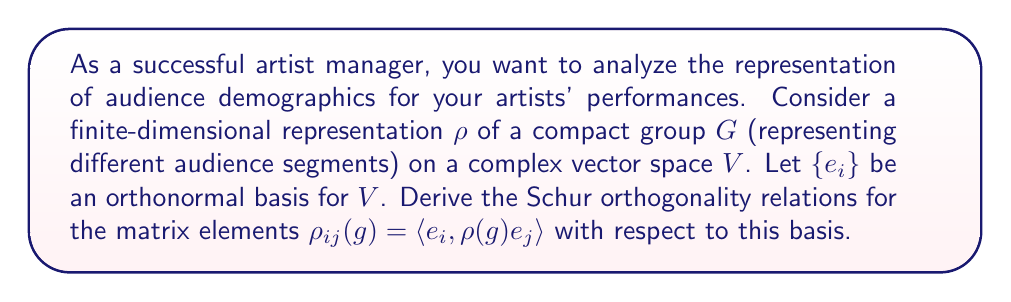Can you answer this question? To derive the Schur orthogonality relations, we'll follow these steps:

1) First, recall that for a compact group $G$, there exists a unique normalized Haar measure $dg$ such that $\int_G dg = 1$.

2) Consider two irreducible representations $\rho$ and $\rho'$ of $G$ on vector spaces $V$ and $V'$ respectively.

3) Define the linear map $T: V \to V'$ by:

   $$T = \int_G \rho'(g)^{-1} A \rho(g) dg$$

   where $A: V \to V'$ is any linear map.

4) By Schur's lemma, if $\rho$ and $\rho'$ are inequivalent, then $T = 0$. If they are equivalent, then $T$ is a scalar multiple of the identity.

5) Applying this to matrix elements, we get:

   $$\int_G \rho'_{ki}(g)^{-1} \rho_{jl}(g) dg = \frac{\delta_{\rho\rho'}\delta_{ij}\delta_{kl}}{\dim V}$$

   where $\delta_{\rho\rho'}$ is 1 if $\rho$ and $\rho'$ are equivalent and 0 otherwise.

6) For unitary representations, $\rho_{ij}(g)^{-1} = \overline{\rho_{ji}(g)}$, so we can write:

   $$\int_G \overline{\rho'_{ik}(g)} \rho_{jl}(g) dg = \frac{\delta_{\rho\rho'}\delta_{ij}\delta_{kl}}{\dim V}$$

This is the Schur orthogonality relation for matrix elements.
Answer: $$\int_G \overline{\rho'_{ik}(g)} \rho_{jl}(g) dg = \frac{\delta_{\rho\rho'}\delta_{ij}\delta_{kl}}{\dim V}$$ 